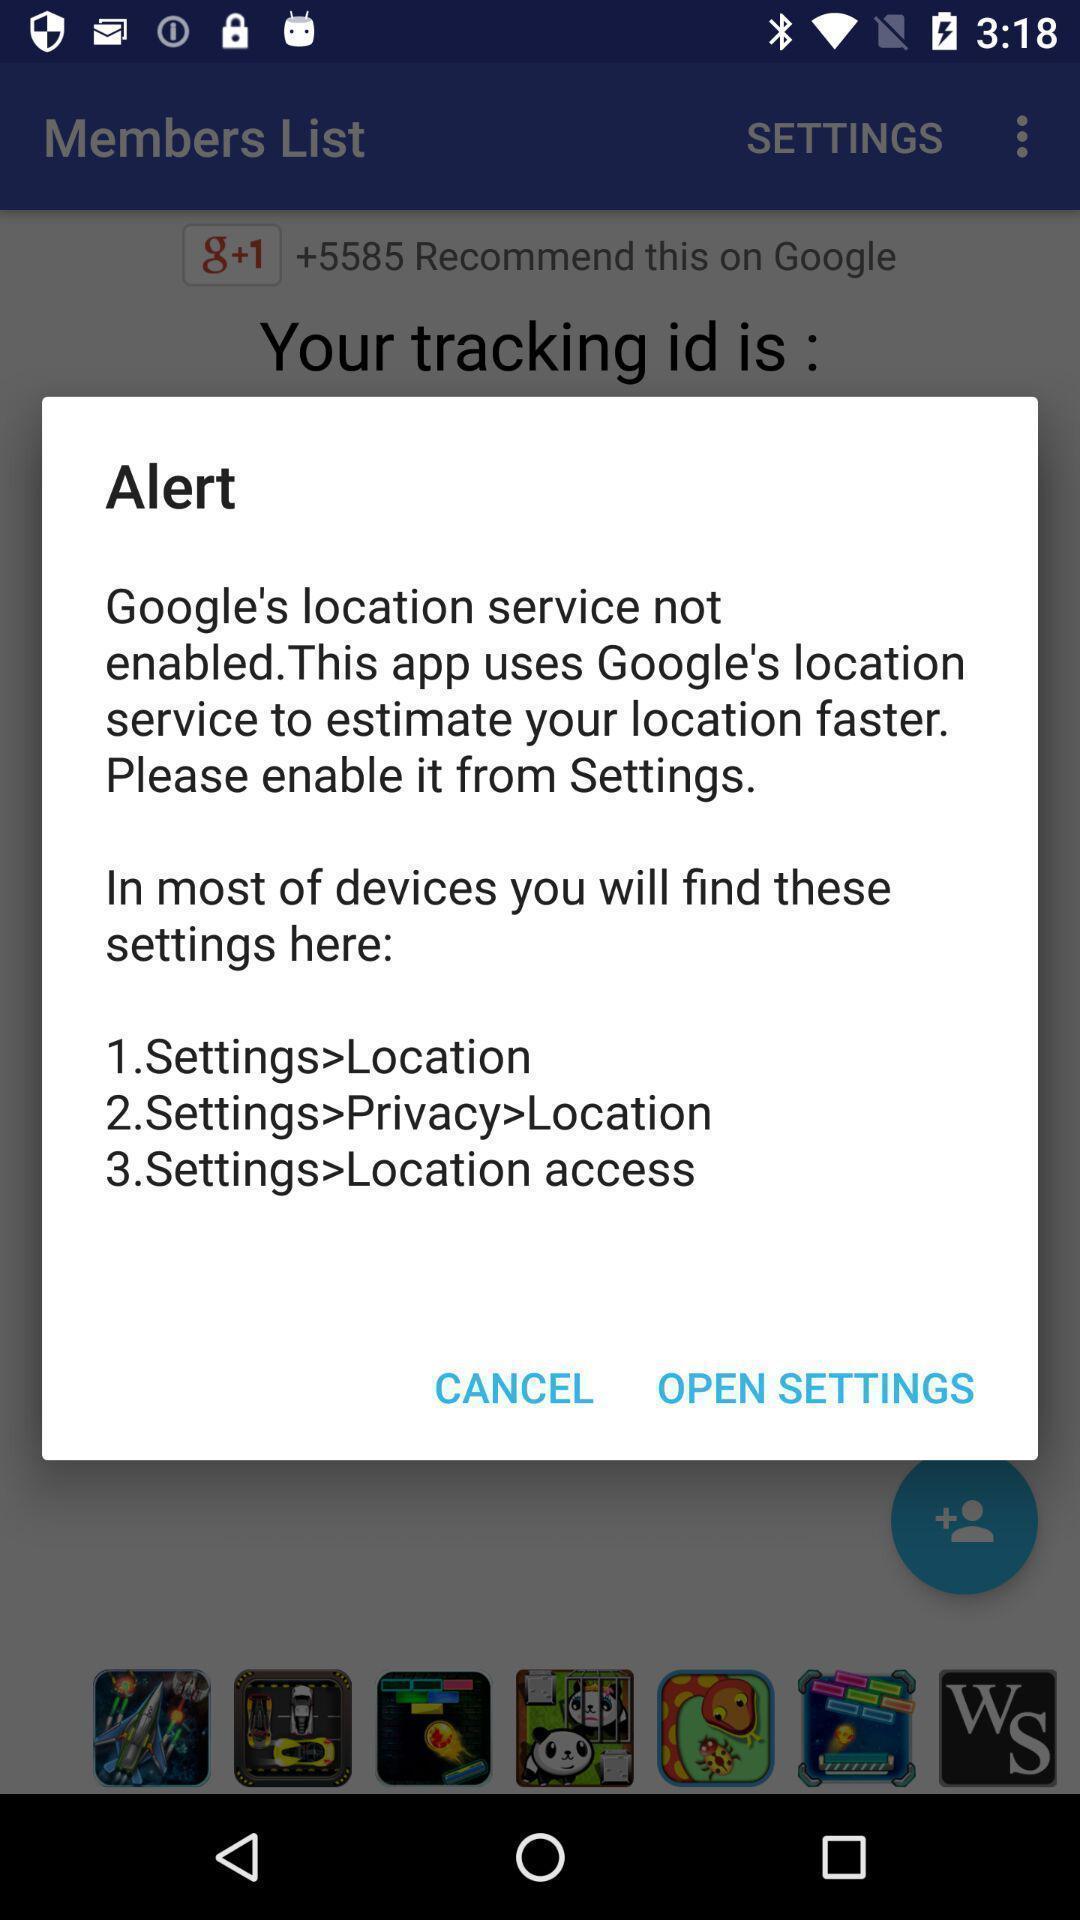Explain the elements present in this screenshot. Pop-up showing alert message to open settings. 